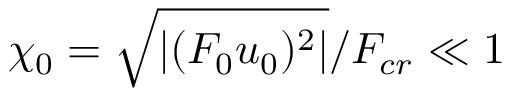Convert formula to latex. <formula><loc_0><loc_0><loc_500><loc_500>\chi _ { 0 } = \sqrt { | ( F _ { 0 } u _ { 0 } ) ^ { 2 } | } / F _ { c r } \ll 1</formula> 